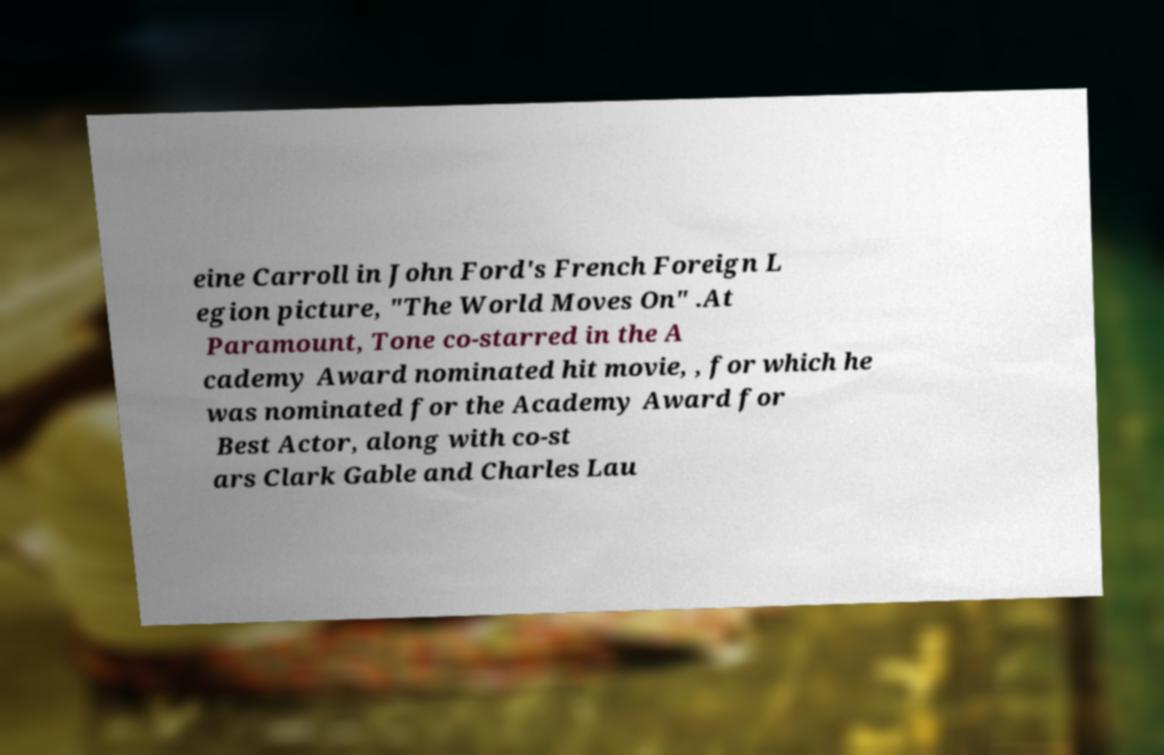Could you assist in decoding the text presented in this image and type it out clearly? eine Carroll in John Ford's French Foreign L egion picture, "The World Moves On" .At Paramount, Tone co-starred in the A cademy Award nominated hit movie, , for which he was nominated for the Academy Award for Best Actor, along with co-st ars Clark Gable and Charles Lau 